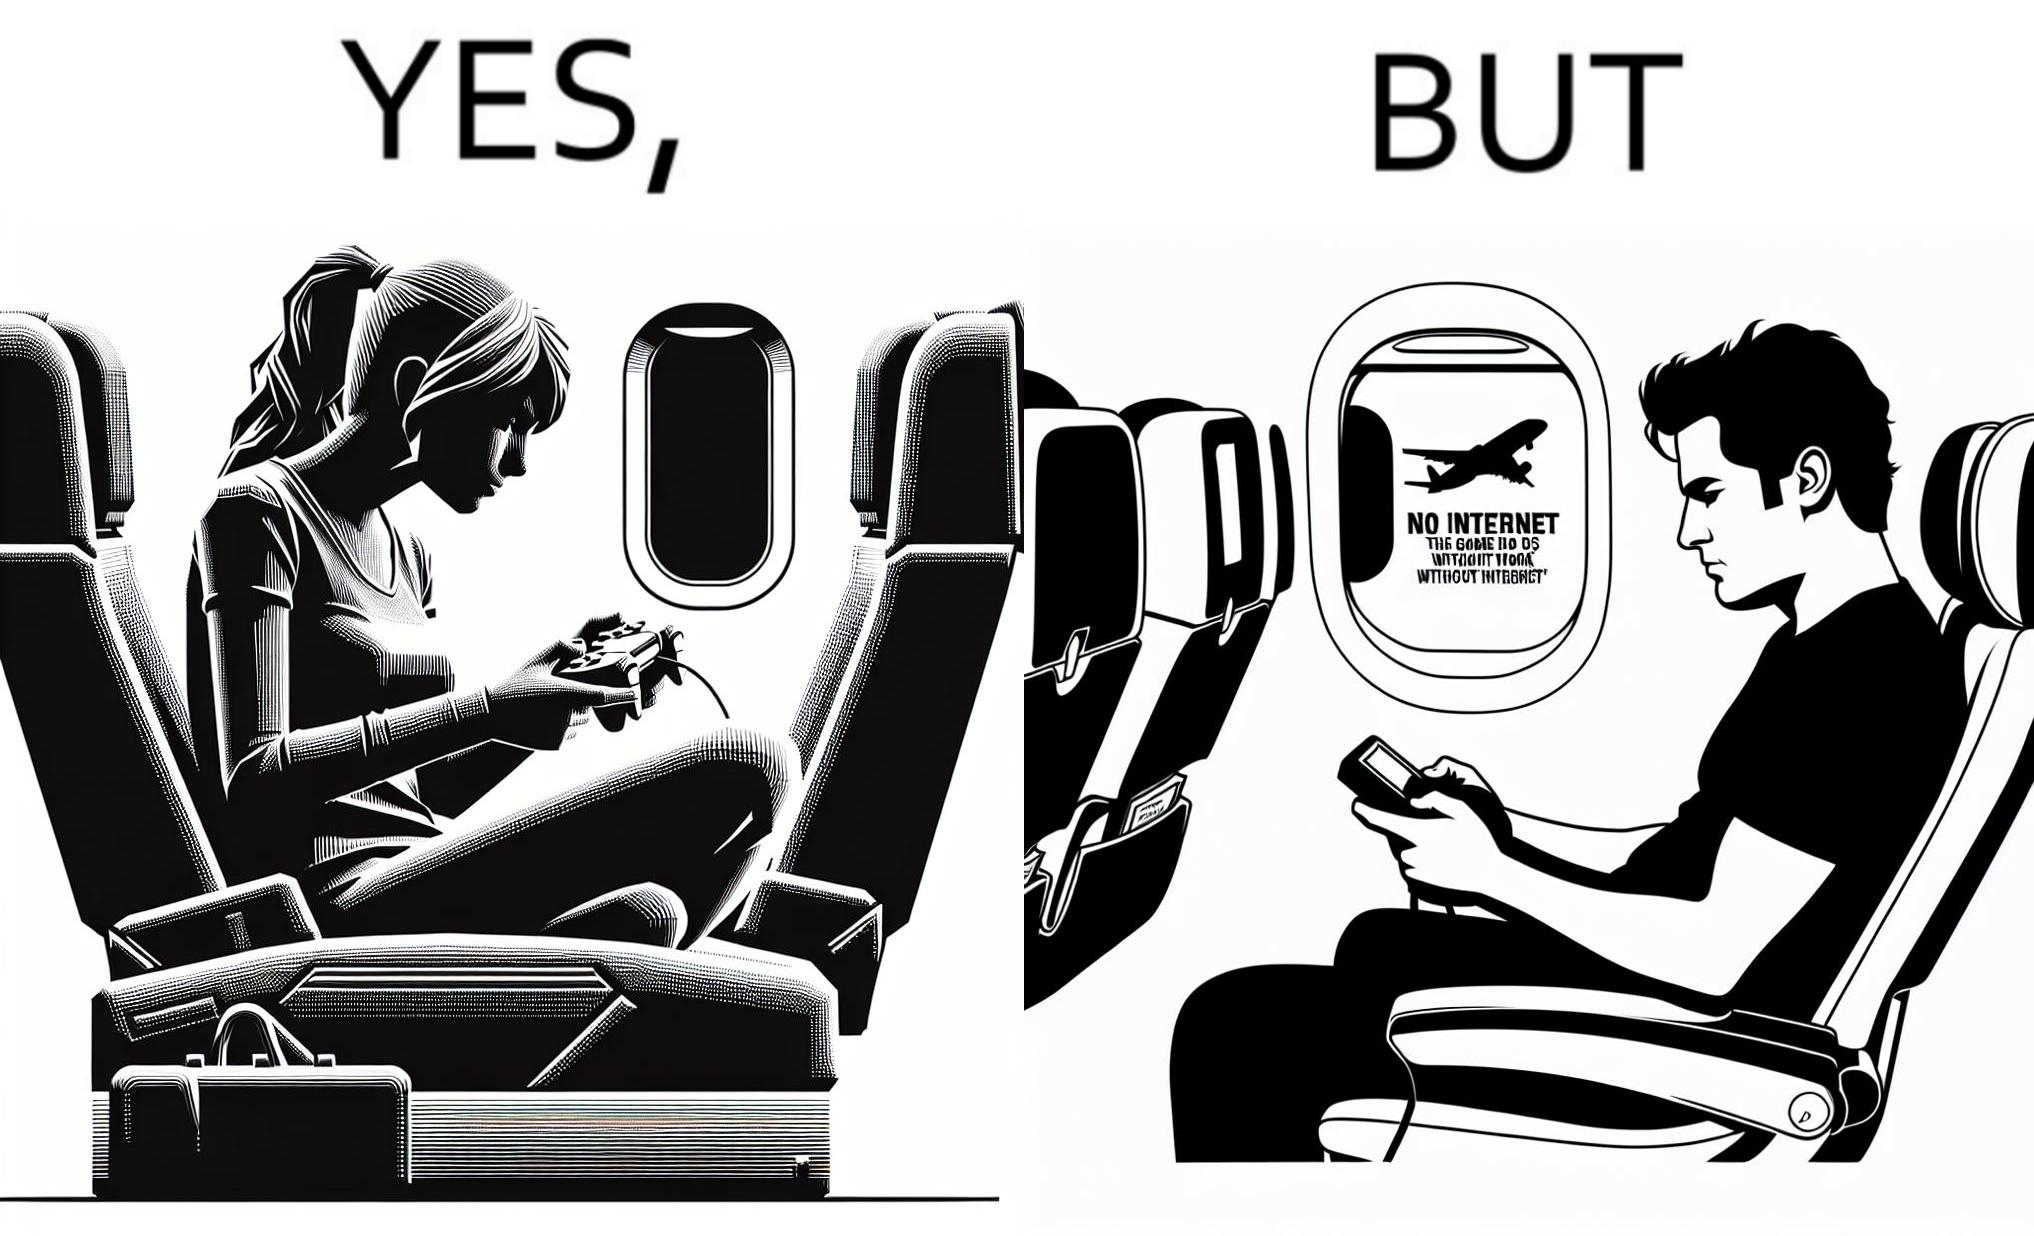Is this image satirical or non-satirical? Yes, this image is satirical. 